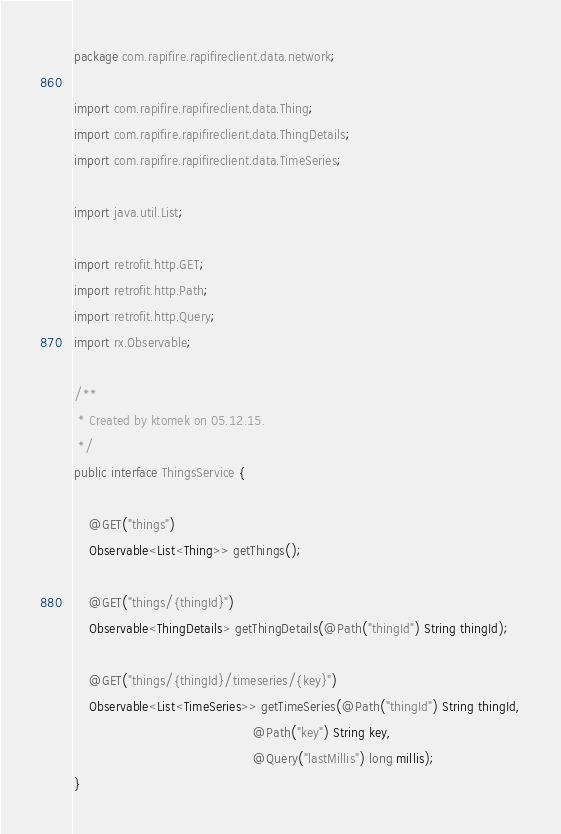Convert code to text. <code><loc_0><loc_0><loc_500><loc_500><_Java_>package com.rapifire.rapifireclient.data.network;

import com.rapifire.rapifireclient.data.Thing;
import com.rapifire.rapifireclient.data.ThingDetails;
import com.rapifire.rapifireclient.data.TimeSeries;

import java.util.List;

import retrofit.http.GET;
import retrofit.http.Path;
import retrofit.http.Query;
import rx.Observable;

/**
 * Created by ktomek on 05.12.15.
 */
public interface ThingsService {

    @GET("things")
    Observable<List<Thing>> getThings();

    @GET("things/{thingId}")
    Observable<ThingDetails> getThingDetails(@Path("thingId") String thingId);

    @GET("things/{thingId}/timeseries/{key}")
    Observable<List<TimeSeries>> getTimeSeries(@Path("thingId") String thingId,
                                               @Path("key") String key,
                                               @Query("lastMillis") long millis);
}
</code> 